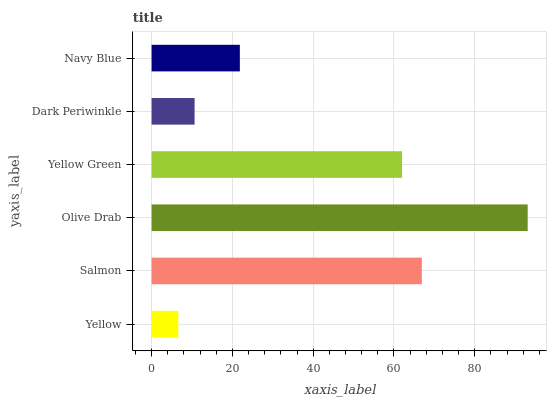Is Yellow the minimum?
Answer yes or no. Yes. Is Olive Drab the maximum?
Answer yes or no. Yes. Is Salmon the minimum?
Answer yes or no. No. Is Salmon the maximum?
Answer yes or no. No. Is Salmon greater than Yellow?
Answer yes or no. Yes. Is Yellow less than Salmon?
Answer yes or no. Yes. Is Yellow greater than Salmon?
Answer yes or no. No. Is Salmon less than Yellow?
Answer yes or no. No. Is Yellow Green the high median?
Answer yes or no. Yes. Is Navy Blue the low median?
Answer yes or no. Yes. Is Navy Blue the high median?
Answer yes or no. No. Is Yellow Green the low median?
Answer yes or no. No. 